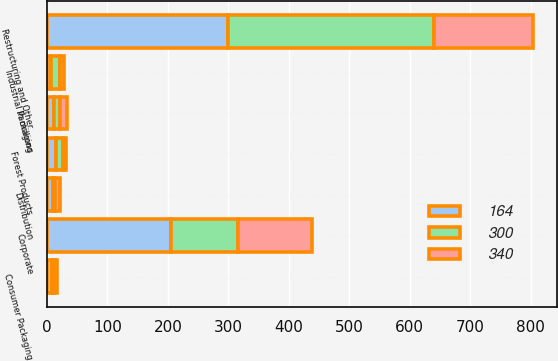<chart> <loc_0><loc_0><loc_500><loc_500><stacked_bar_chart><ecel><fcel>In millions<fcel>Industrial Packaging<fcel>Consumer Packaging<fcel>Distribution<fcel>Forest Products<fcel>Corporate<fcel>Restructuring and Other<nl><fcel>164<fcel>11<fcel>7<fcel>9<fcel>10<fcel>15<fcel>205<fcel>300<nl><fcel>300<fcel>11<fcel>14<fcel>2<fcel>4<fcel>12<fcel>111<fcel>340<nl><fcel>340<fcel>11<fcel>7<fcel>5<fcel>7<fcel>5<fcel>122<fcel>164<nl></chart> 